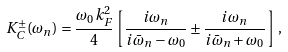<formula> <loc_0><loc_0><loc_500><loc_500>K ^ { \pm } _ { C } ( \omega _ { n } ) = \frac { \omega _ { 0 } k ^ { 2 } _ { F } } { 4 } \left [ \frac { i \omega _ { n } } { i \bar { \omega } _ { n } - \omega _ { 0 } } \pm \frac { i \omega _ { n } } { i \bar { \omega } _ { n } + \omega _ { 0 } } \right ] \, ,</formula> 